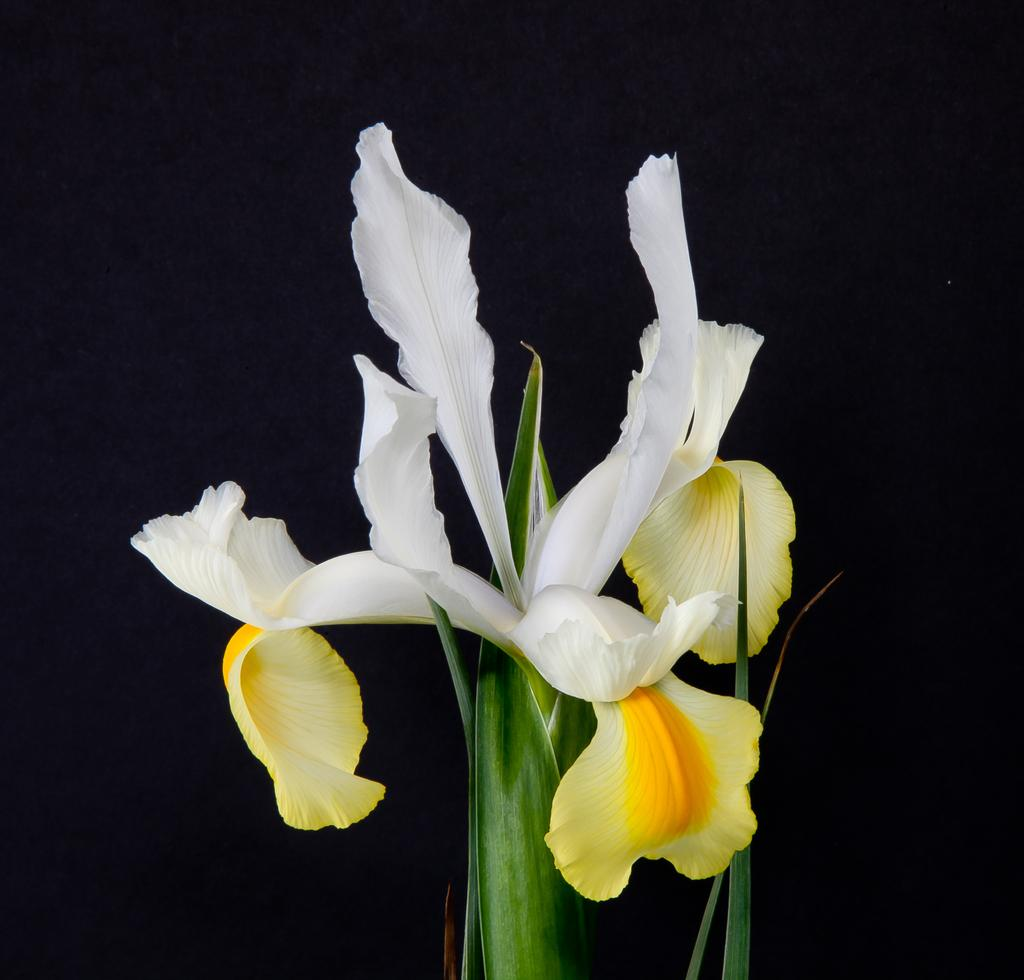What type of plant is featured in the image? There is a flower in the image. What colors can be seen on the flower? The flower has white and yellow colors. What other plant element is visible in the image? There is a plant with leaves at the bottom of the image. How would you describe the overall lighting in the image? The background of the image is dark. What advice does the manager give to the brothers in the image? There are no people, including a manager or brothers, present in the image. The image only features a flower and a plant with leaves. 